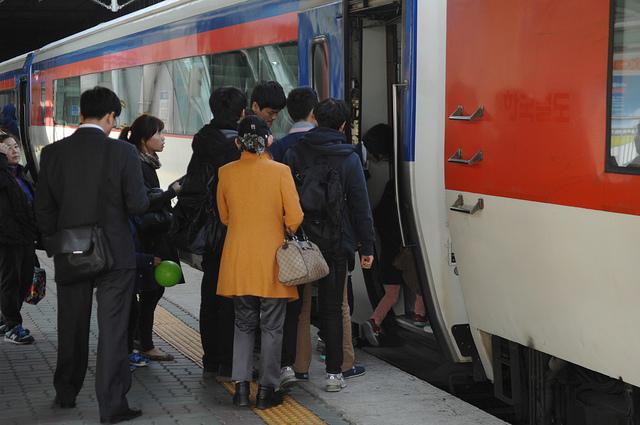Do most of the people have luggage?
Concise answer only. No. Are the people getting on or off the bus?
Keep it brief. On. How many people are shown?
Keep it brief. 10. Is the woman's coat red?
Keep it brief. No. Are the people walking toward the train?
Short answer required. Yes. Is there a light on the side of the train?
Short answer required. No. What are they getting on?
Quick response, please. Train. Are these people Asian?
Short answer required. Yes. 